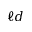<formula> <loc_0><loc_0><loc_500><loc_500>\ell d</formula> 